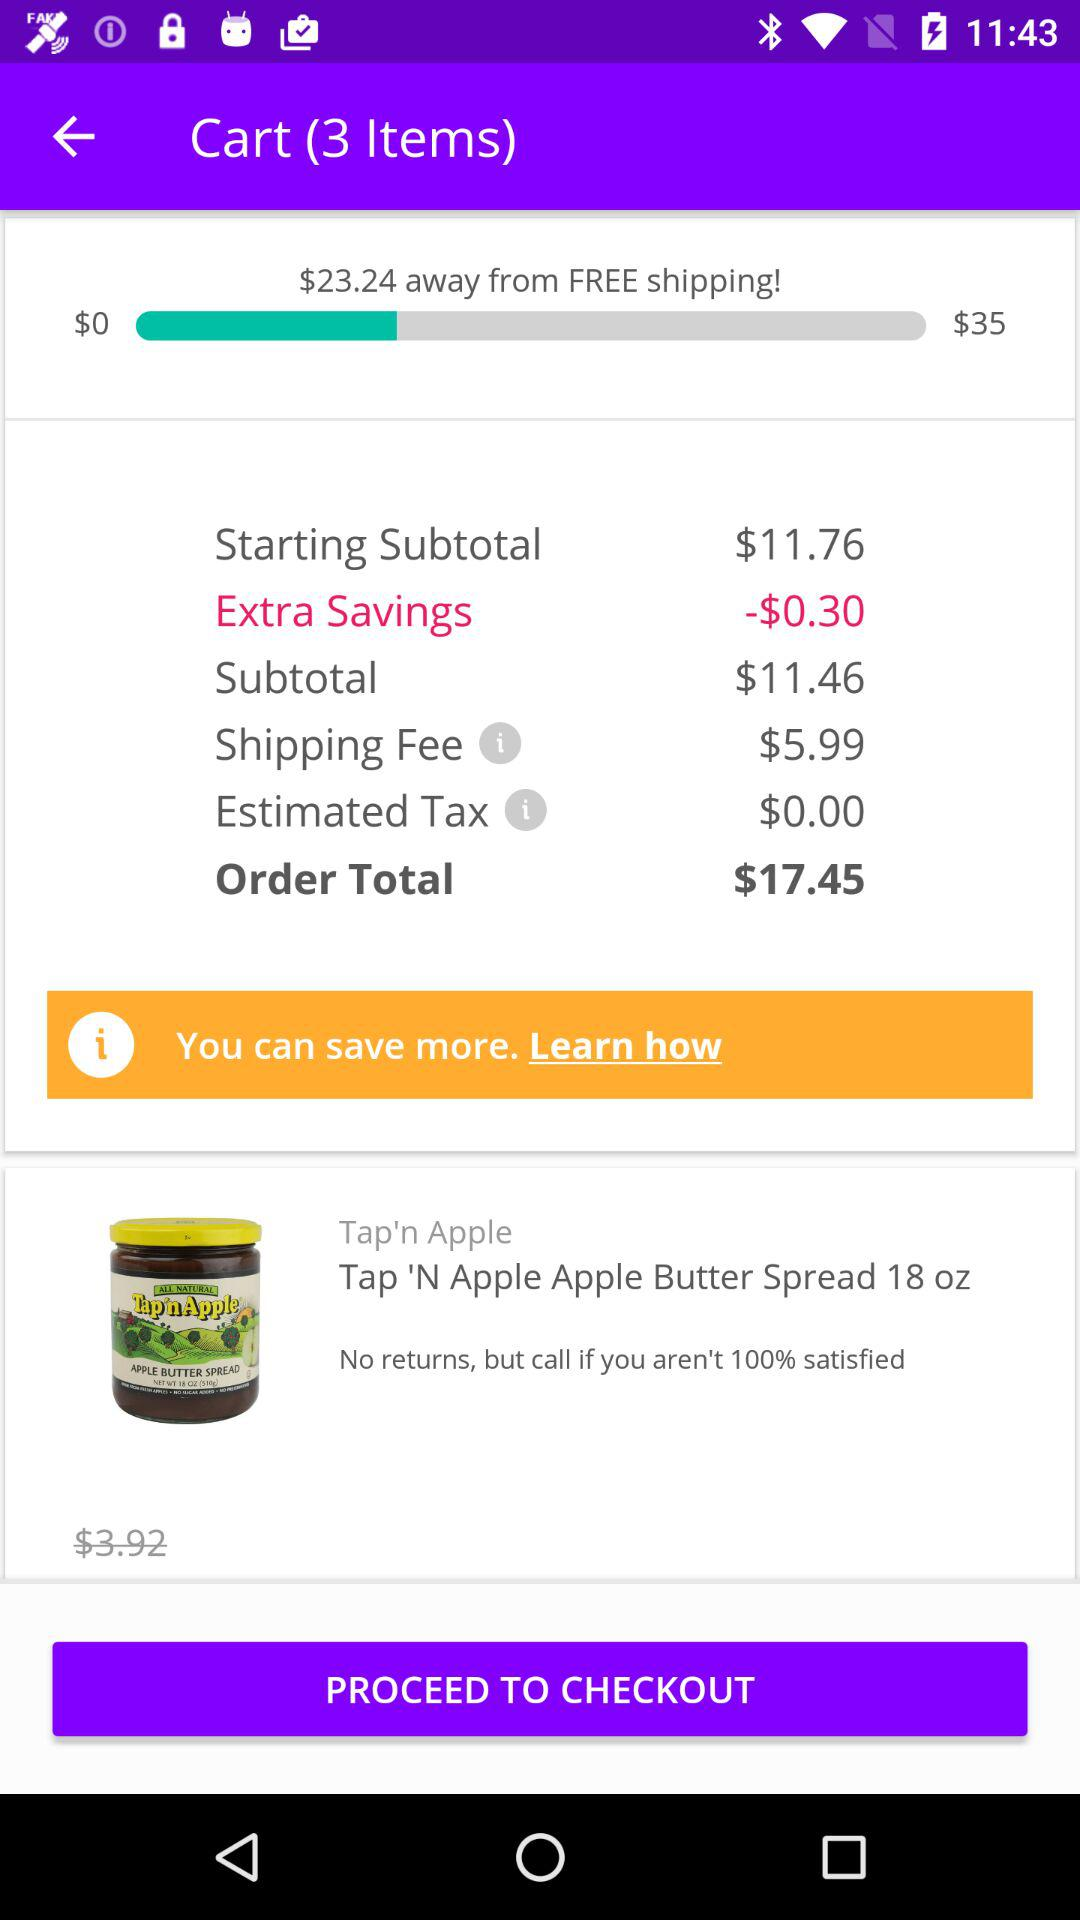How much more do I need to spend to get free shipping?
Answer the question using a single word or phrase. $23.24 